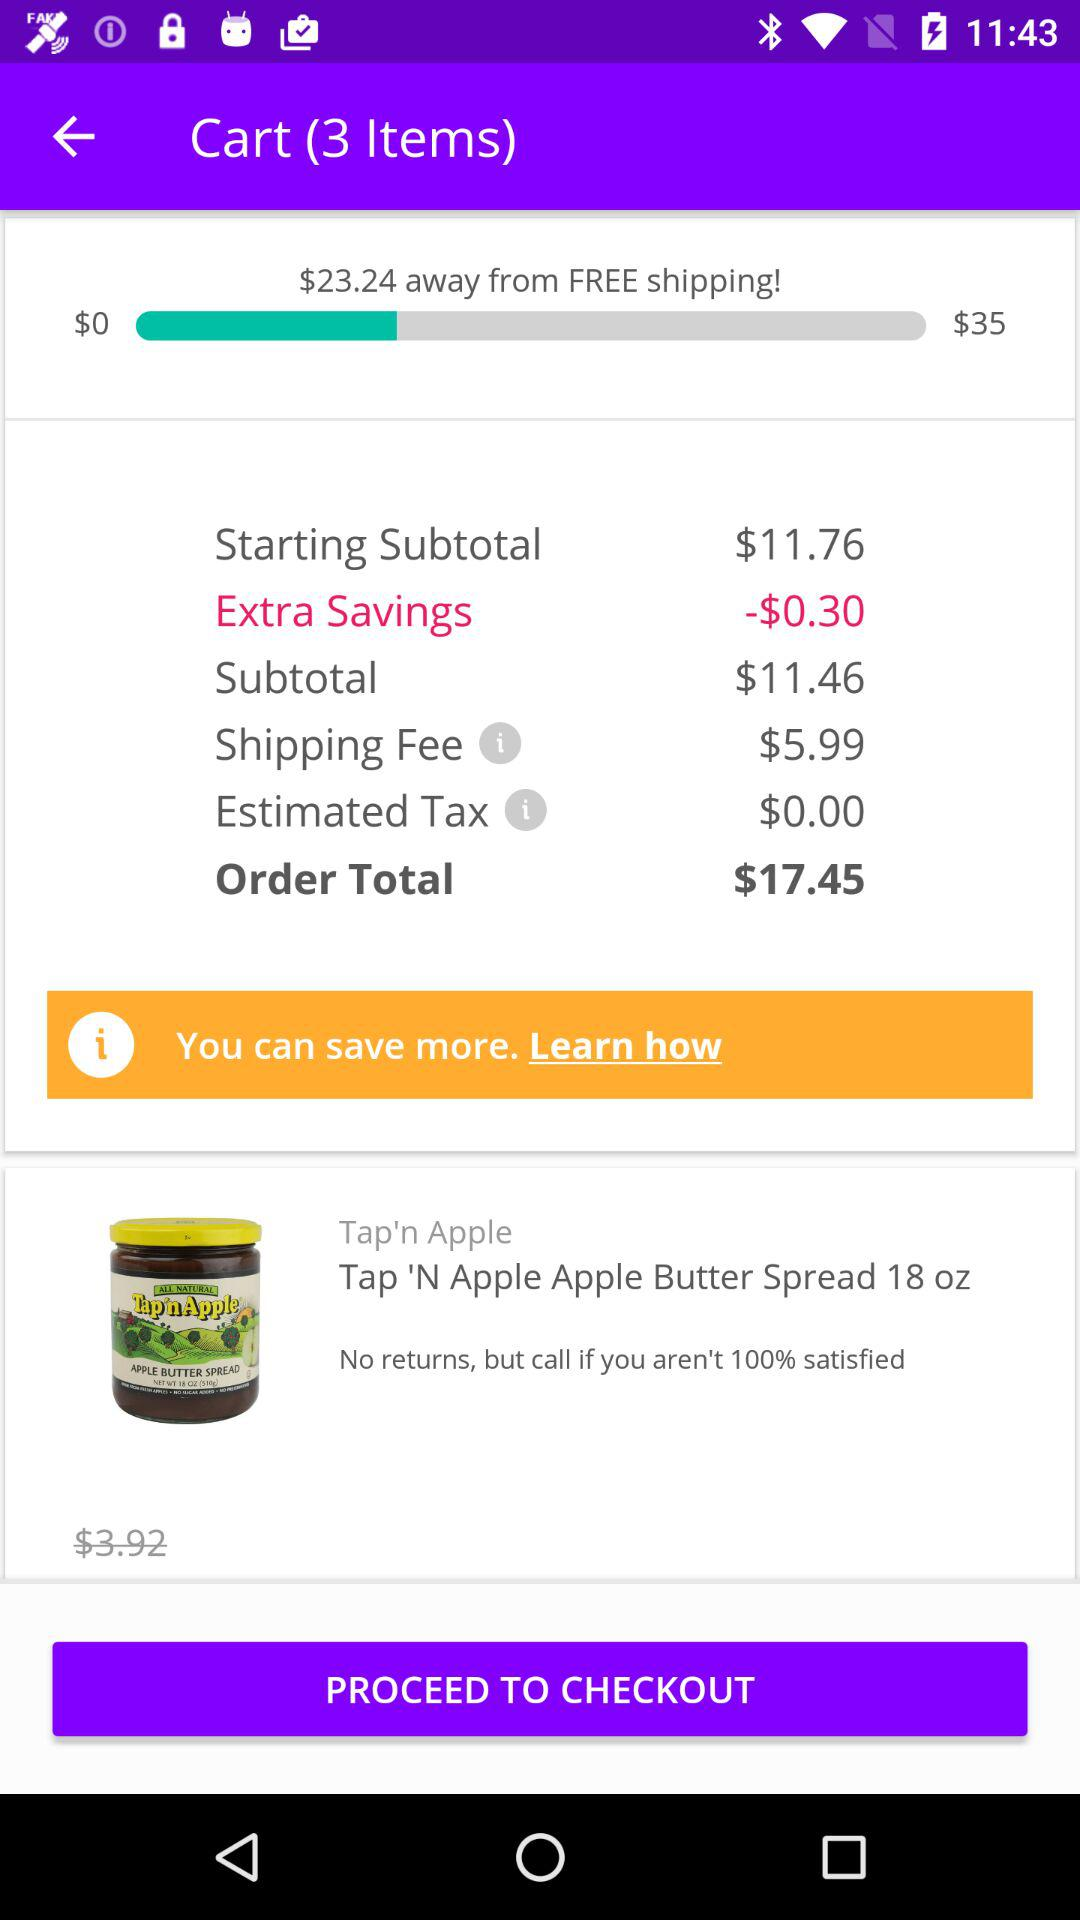How much more do I need to spend to get free shipping?
Answer the question using a single word or phrase. $23.24 